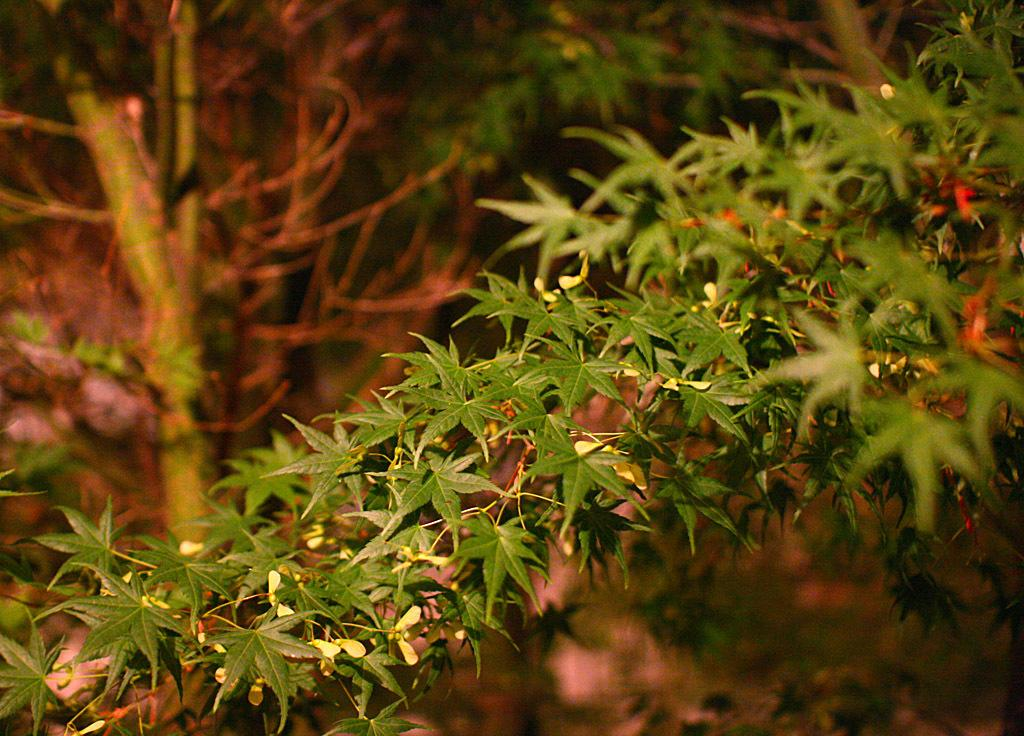What type of plant is featured in the image? There is a plant with tiny flowers in the image. Can you describe the background of the image? There are plants visible in the background of the image. What type of mine can be seen in the image? There is no mine present in the image; it features a plant with tiny flowers and plants in the background. Is there a bear visible in the image? No, there is no bear present in the image. 